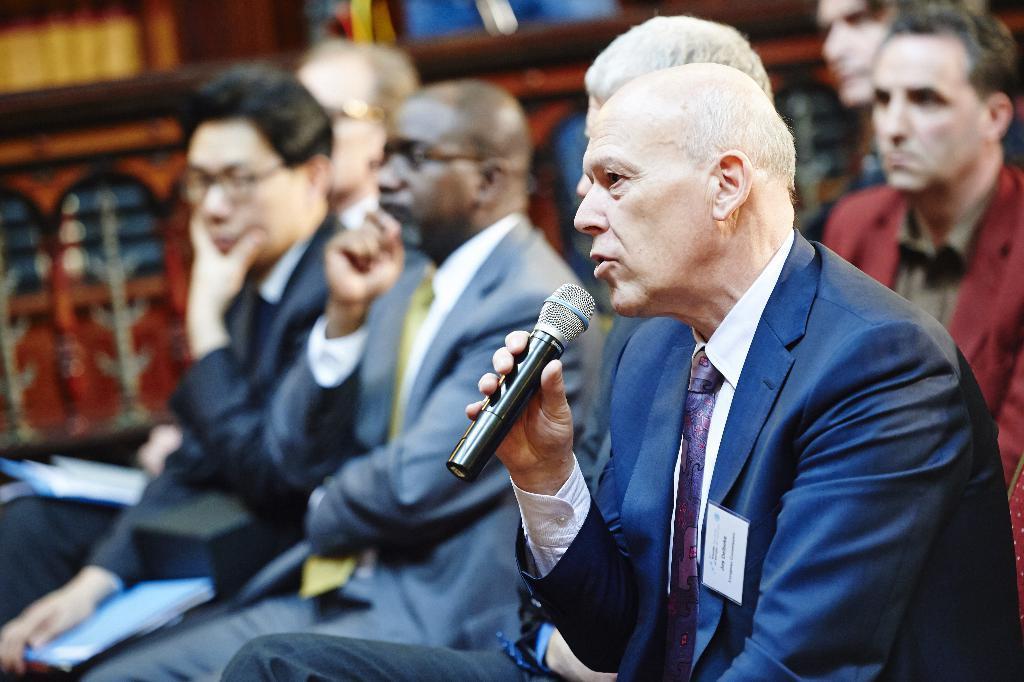Could you give a brief overview of what you see in this image? In this picture I can see few people seated and couple of them holding files and I can see a man holding a microphone in his hand and speaking. looks like few books in the bookshelf on the back. 